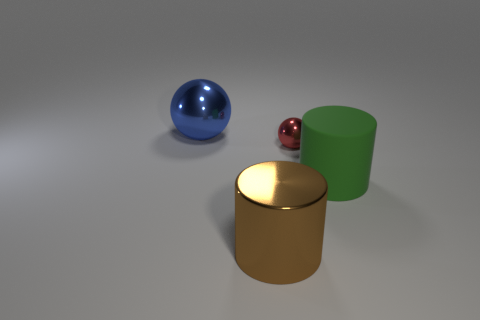Can you tell me which of the objects on the table has the smoothest surface? The blue spherical object appears to have the smoothest surface, reflecting light evenly and showing no visible texture. 